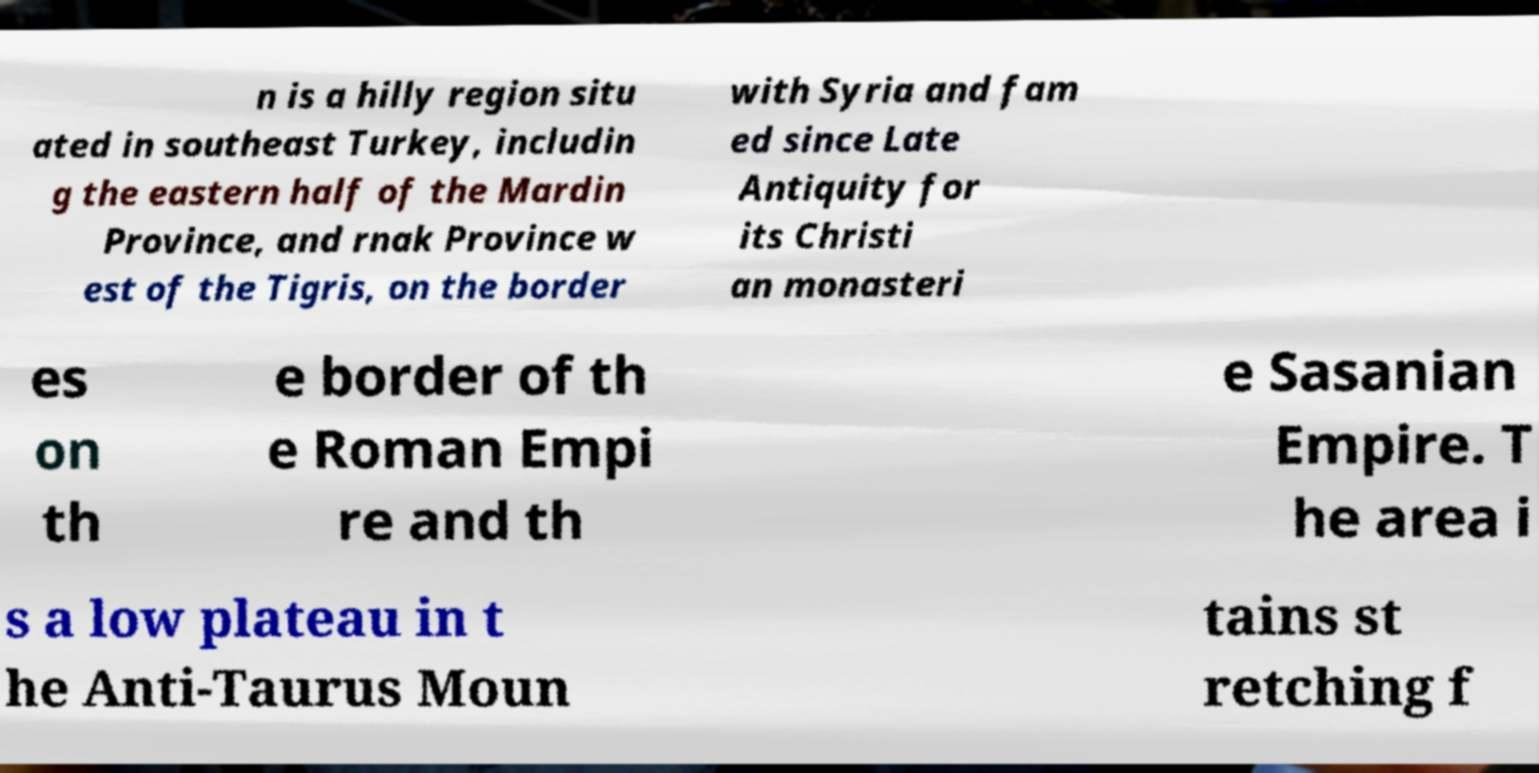Please identify and transcribe the text found in this image. n is a hilly region situ ated in southeast Turkey, includin g the eastern half of the Mardin Province, and rnak Province w est of the Tigris, on the border with Syria and fam ed since Late Antiquity for its Christi an monasteri es on th e border of th e Roman Empi re and th e Sasanian Empire. T he area i s a low plateau in t he Anti-Taurus Moun tains st retching f 